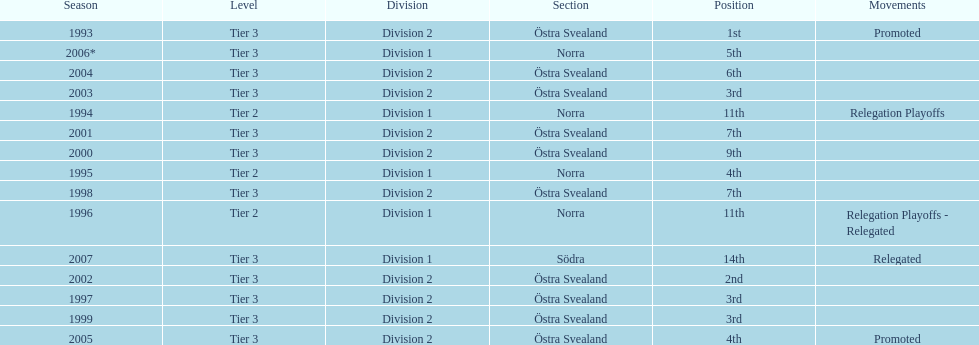Between 2007 and 2002, which year experienced more accomplishments? 2002. 